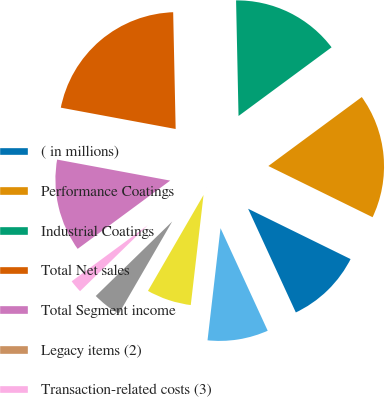Convert chart to OTSL. <chart><loc_0><loc_0><loc_500><loc_500><pie_chart><fcel>( in millions)<fcel>Performance Coatings<fcel>Industrial Coatings<fcel>Total Net sales<fcel>Total Segment income<fcel>Legacy items (2)<fcel>Transaction-related costs (3)<fcel>Interest expense net of<fcel>Corporate unallocated (1)<fcel>Total Income before income<nl><fcel>10.87%<fcel>17.39%<fcel>15.22%<fcel>21.74%<fcel>13.04%<fcel>0.0%<fcel>2.18%<fcel>4.35%<fcel>6.52%<fcel>8.7%<nl></chart> 